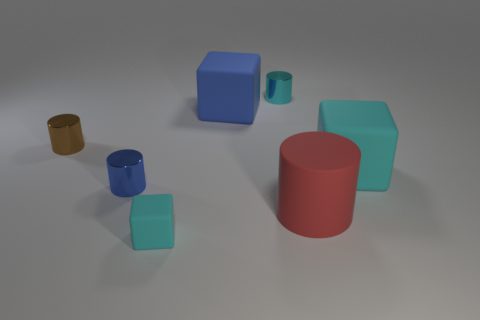Subtract all small rubber blocks. How many blocks are left? 2 Add 2 small shiny cylinders. How many objects exist? 9 Subtract all blue cubes. How many cubes are left? 2 Subtract all red cylinders. Subtract all blocks. How many objects are left? 3 Add 4 cylinders. How many cylinders are left? 8 Add 4 blue metal cylinders. How many blue metal cylinders exist? 5 Subtract 0 purple cubes. How many objects are left? 7 Subtract all cylinders. How many objects are left? 3 Subtract 2 cylinders. How many cylinders are left? 2 Subtract all purple cylinders. Subtract all red spheres. How many cylinders are left? 4 